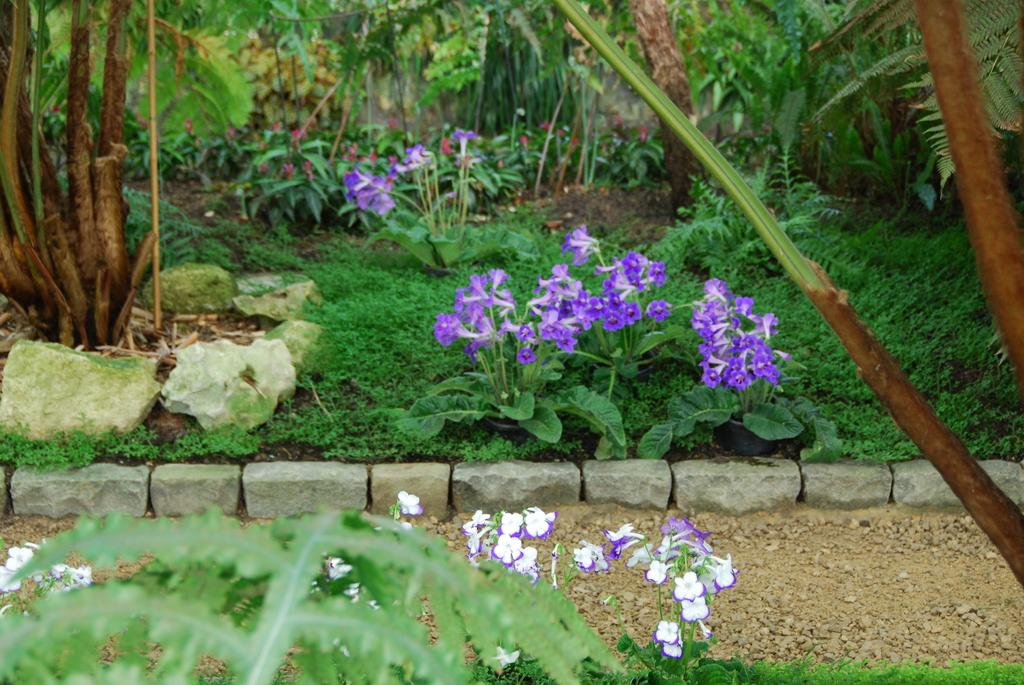What type of living organisms can be seen in the image? Plants and flowers can be seen in the image. Can you describe the flowers in the image? Yes, there are flowers in the image. What type of tent can be seen in the image? There is no tent present in the image. What advice can be given to the flowers in the image? The image does not depict a situation where advice can be given to the flowers, as it is a still image. 